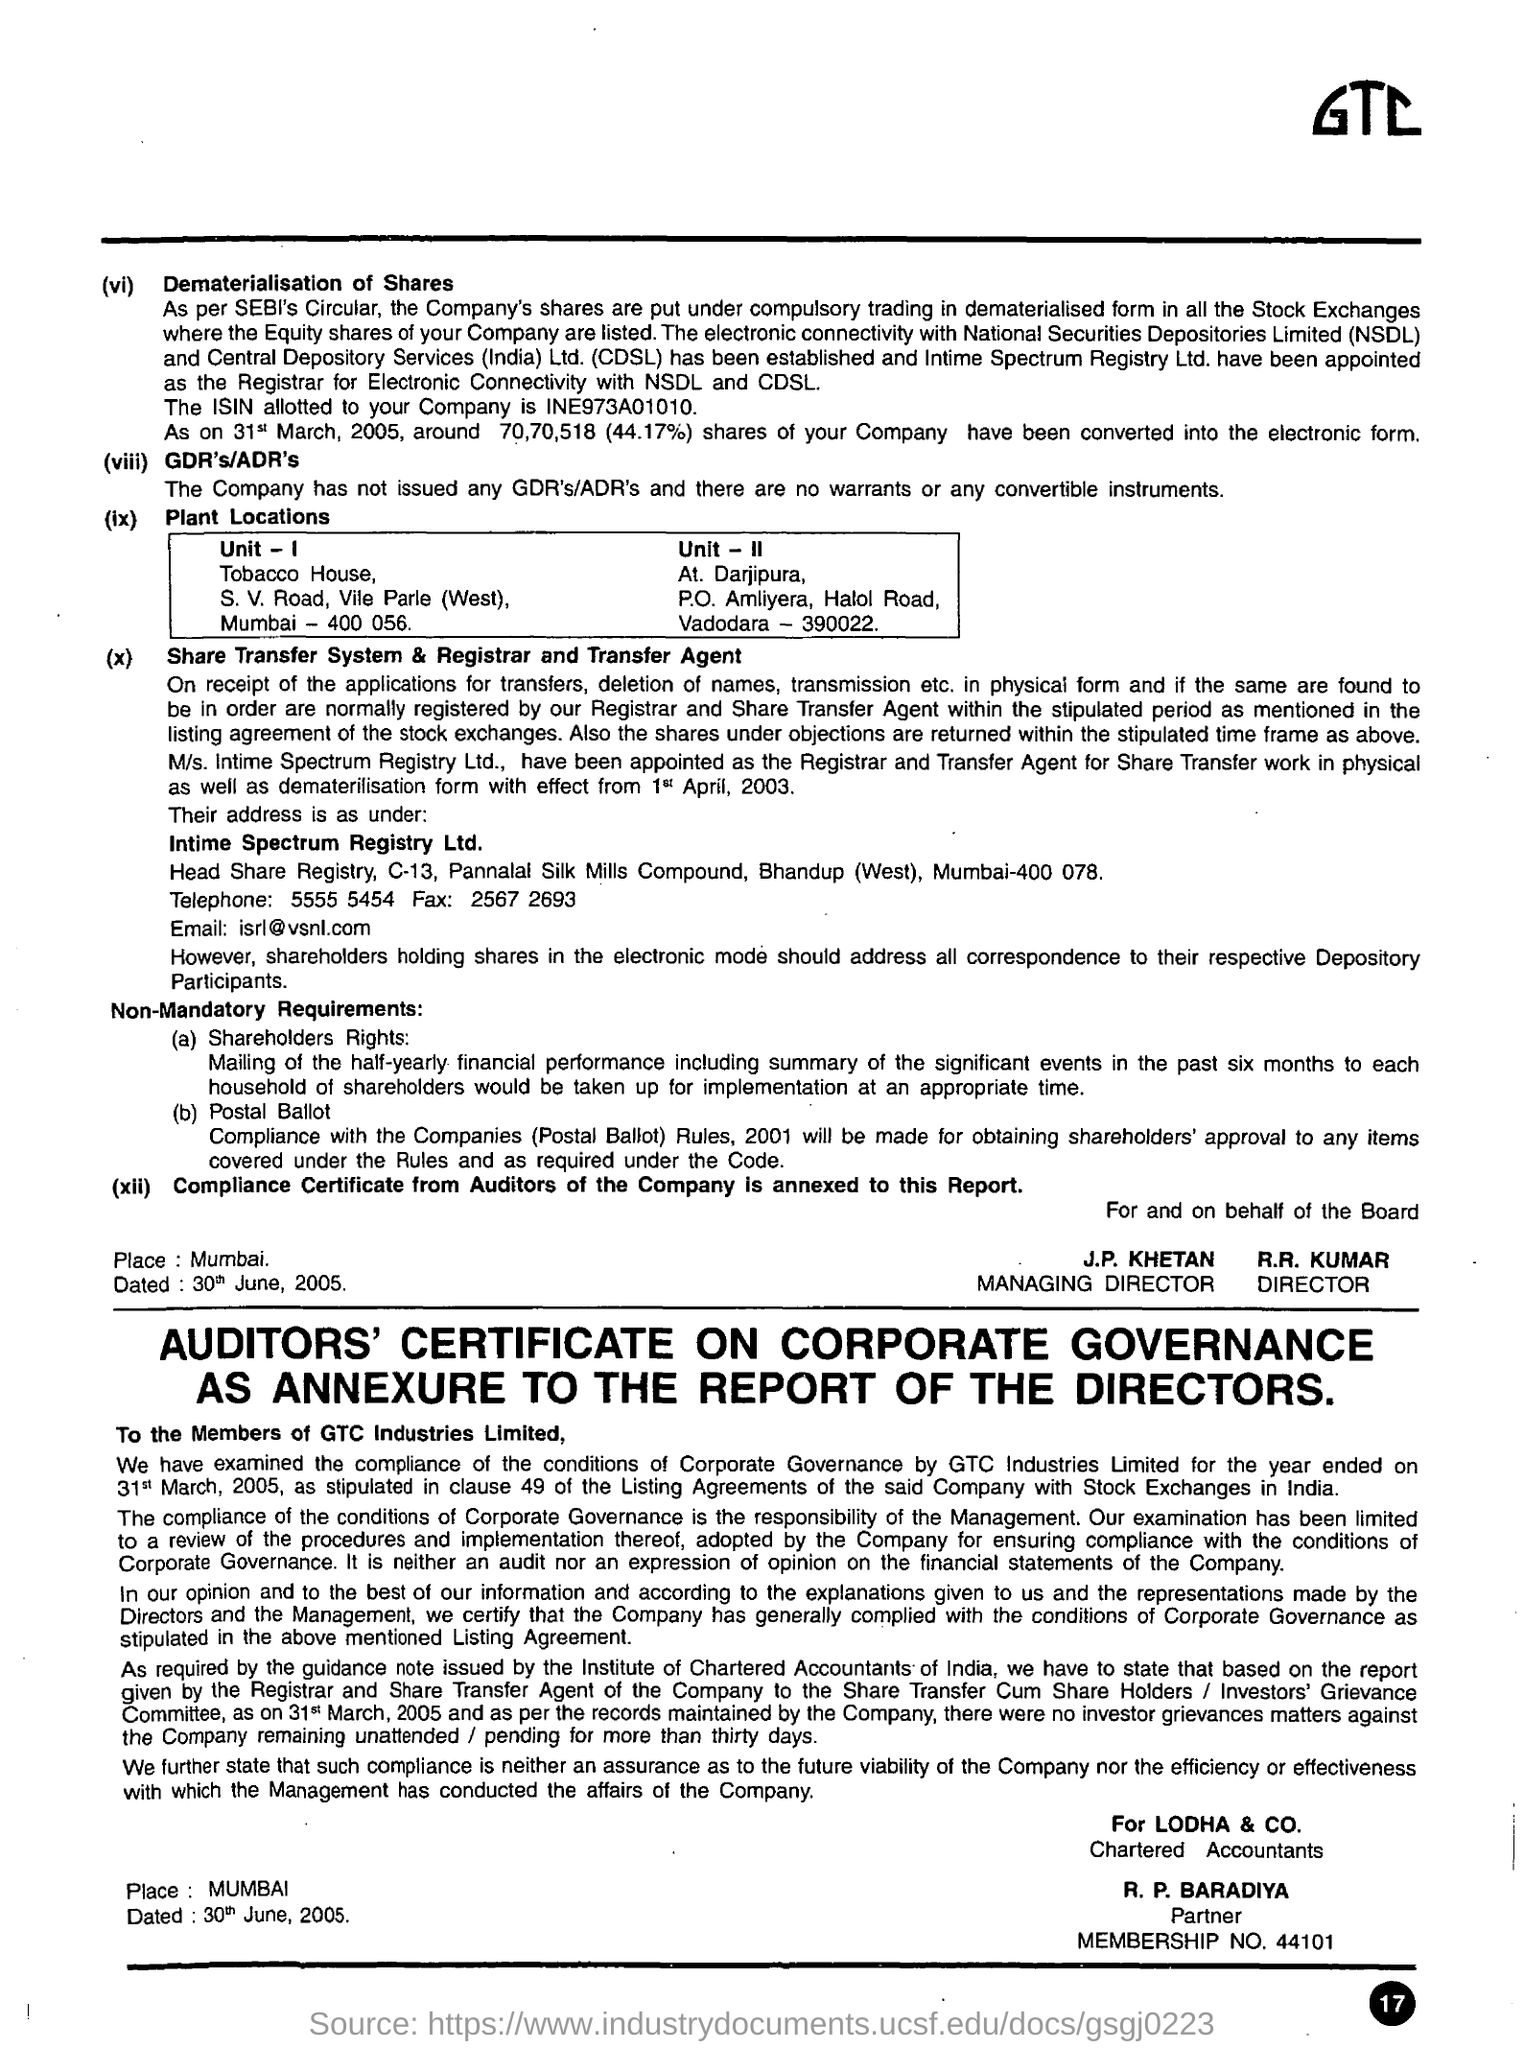List a handful of essential elements in this visual. The managing director is J.P. KHETAN. R.R. Kumar is the Director. 